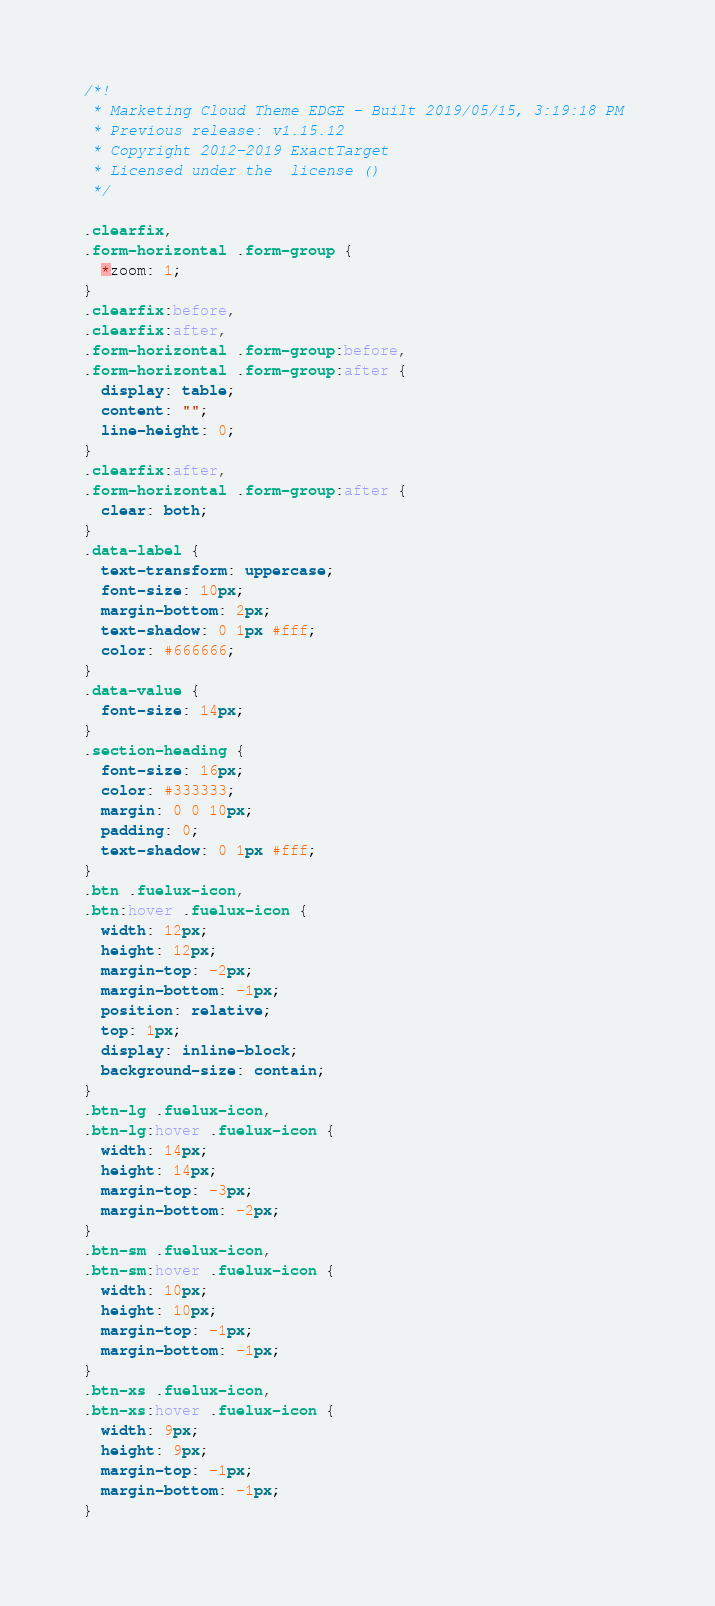Convert code to text. <code><loc_0><loc_0><loc_500><loc_500><_CSS_>/*!
 * Marketing Cloud Theme EDGE - Built 2019/05/15, 3:19:18 PM 
 * Previous release: v1.15.12 
 * Copyright 2012-2019 ExactTarget
 * Licensed under the  license ()
 */

.clearfix,
.form-horizontal .form-group {
  *zoom: 1;
}
.clearfix:before,
.clearfix:after,
.form-horizontal .form-group:before,
.form-horizontal .form-group:after {
  display: table;
  content: "";
  line-height: 0;
}
.clearfix:after,
.form-horizontal .form-group:after {
  clear: both;
}
.data-label {
  text-transform: uppercase;
  font-size: 10px;
  margin-bottom: 2px;
  text-shadow: 0 1px #fff;
  color: #666666;
}
.data-value {
  font-size: 14px;
}
.section-heading {
  font-size: 16px;
  color: #333333;
  margin: 0 0 10px;
  padding: 0;
  text-shadow: 0 1px #fff;
}
.btn .fuelux-icon,
.btn:hover .fuelux-icon {
  width: 12px;
  height: 12px;
  margin-top: -2px;
  margin-bottom: -1px;
  position: relative;
  top: 1px;
  display: inline-block;
  background-size: contain;
}
.btn-lg .fuelux-icon,
.btn-lg:hover .fuelux-icon {
  width: 14px;
  height: 14px;
  margin-top: -3px;
  margin-bottom: -2px;
}
.btn-sm .fuelux-icon,
.btn-sm:hover .fuelux-icon {
  width: 10px;
  height: 10px;
  margin-top: -1px;
  margin-bottom: -1px;
}
.btn-xs .fuelux-icon,
.btn-xs:hover .fuelux-icon {
  width: 9px;
  height: 9px;
  margin-top: -1px;
  margin-bottom: -1px;
}</code> 